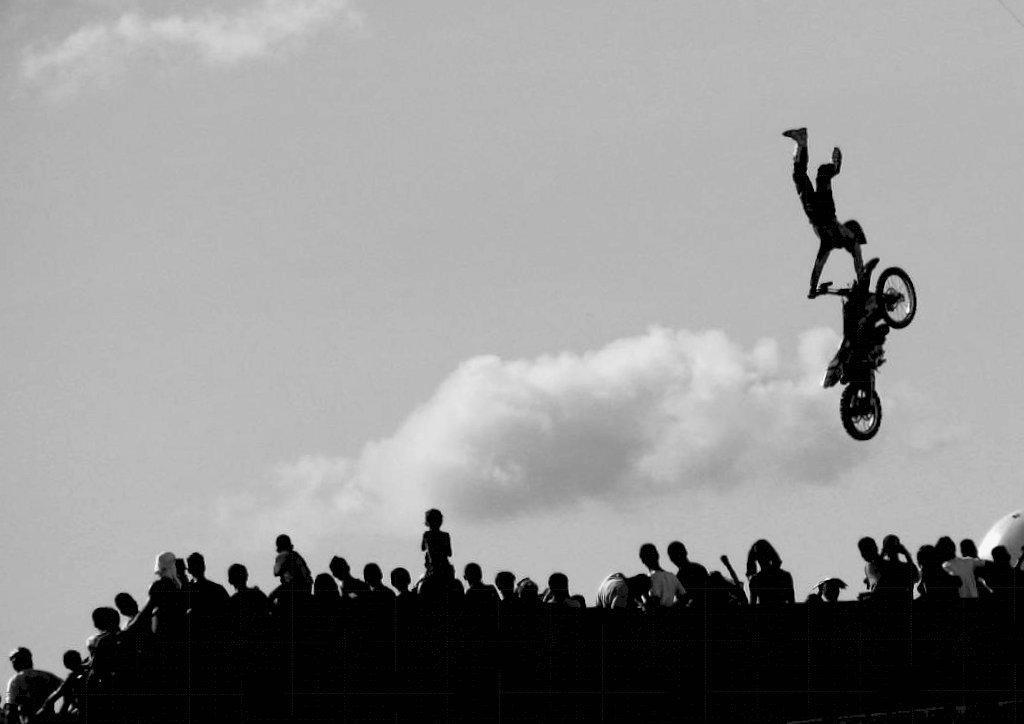Can you describe this image briefly? In this image, we can see some people standing, at the right side there is a man holding the bike, at the top there is a sky. 